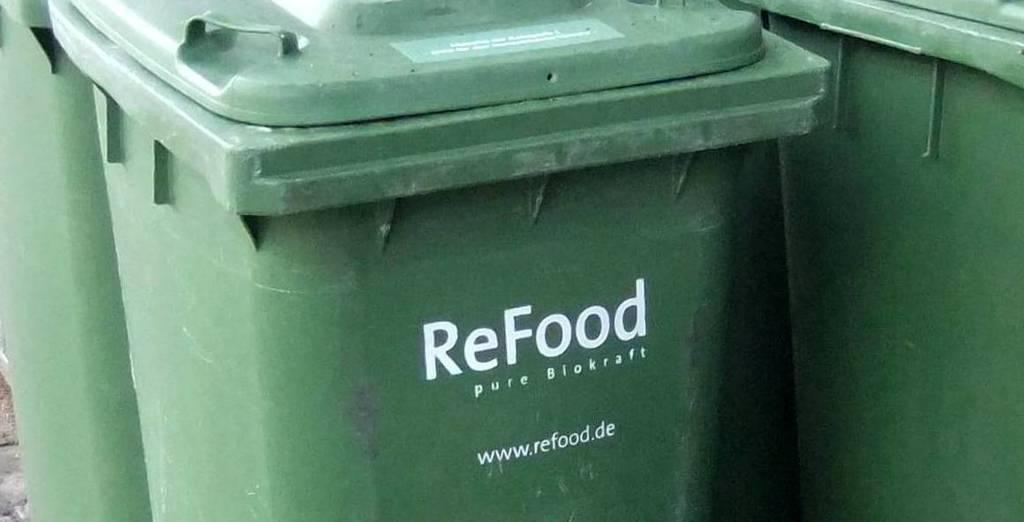<image>
Create a compact narrative representing the image presented. A large green trash container with the word ReFood written on it. 